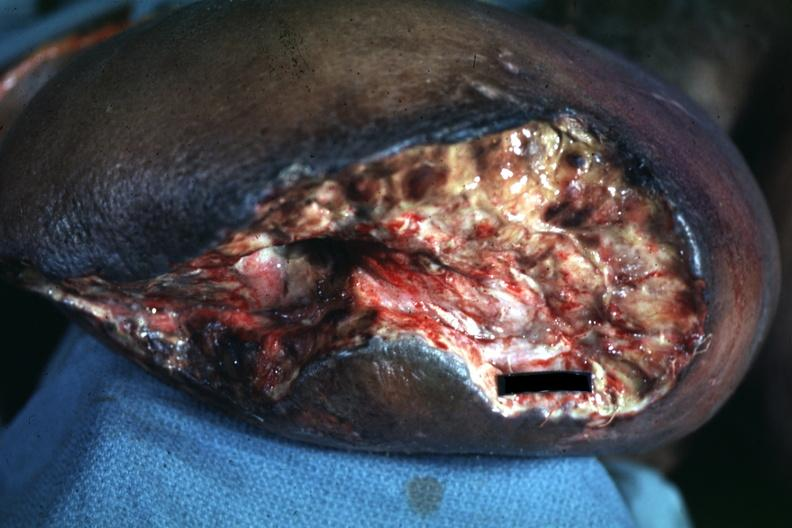what does wound appear?
Answer the question using a single word or phrase. To be mid thigh 